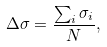Convert formula to latex. <formula><loc_0><loc_0><loc_500><loc_500>\Delta \sigma = \frac { \sum _ { i } \sigma _ { i } } { N } ,</formula> 